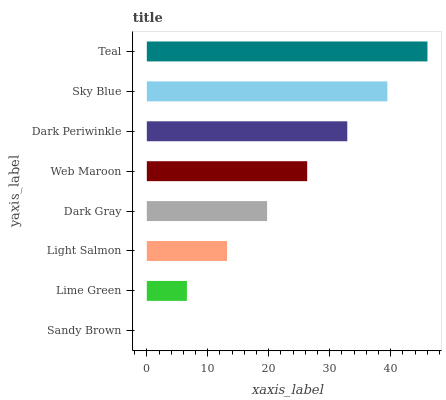Is Sandy Brown the minimum?
Answer yes or no. Yes. Is Teal the maximum?
Answer yes or no. Yes. Is Lime Green the minimum?
Answer yes or no. No. Is Lime Green the maximum?
Answer yes or no. No. Is Lime Green greater than Sandy Brown?
Answer yes or no. Yes. Is Sandy Brown less than Lime Green?
Answer yes or no. Yes. Is Sandy Brown greater than Lime Green?
Answer yes or no. No. Is Lime Green less than Sandy Brown?
Answer yes or no. No. Is Web Maroon the high median?
Answer yes or no. Yes. Is Dark Gray the low median?
Answer yes or no. Yes. Is Sandy Brown the high median?
Answer yes or no. No. Is Light Salmon the low median?
Answer yes or no. No. 